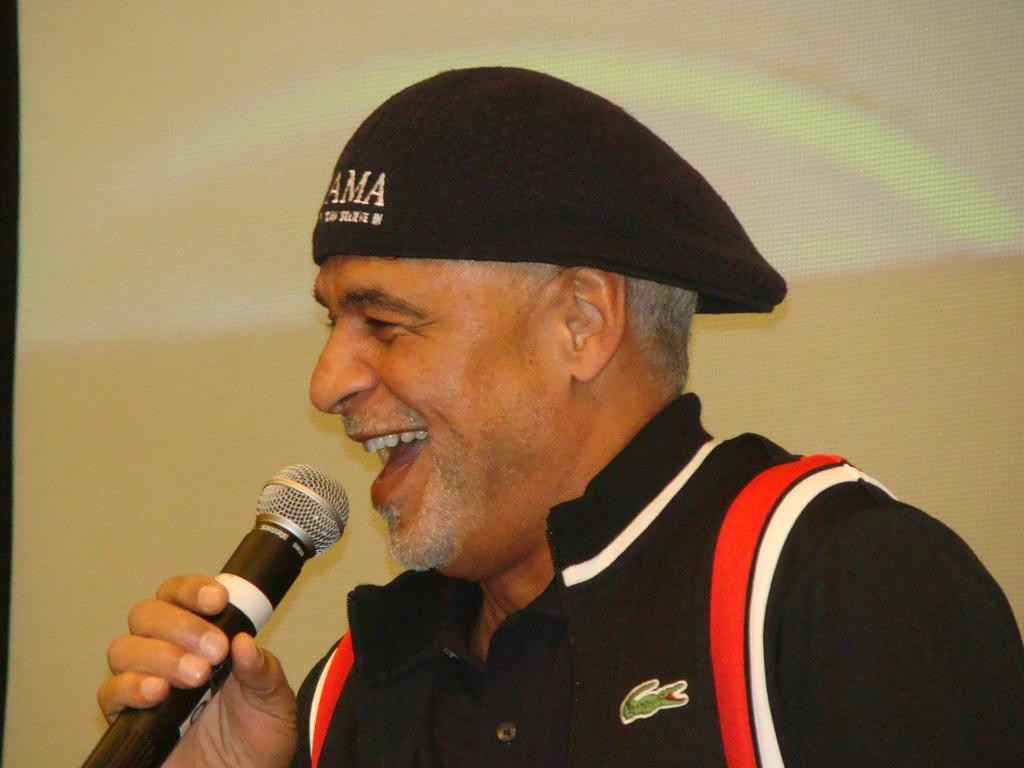What is the main subject of the image? The main subject of the image is a man. What is the man holding in his hand? The man is holding a mic in his hand. How would you describe the man's expression? The man's expression is described as "cheating." What type of clothing is the man wearing on his head? The man is wearing a hat. What type of fog can be seen in the image? There is no fog present in the image. Can you tell me how many lamps are visible in the image? There are no lamps visible in the image. 